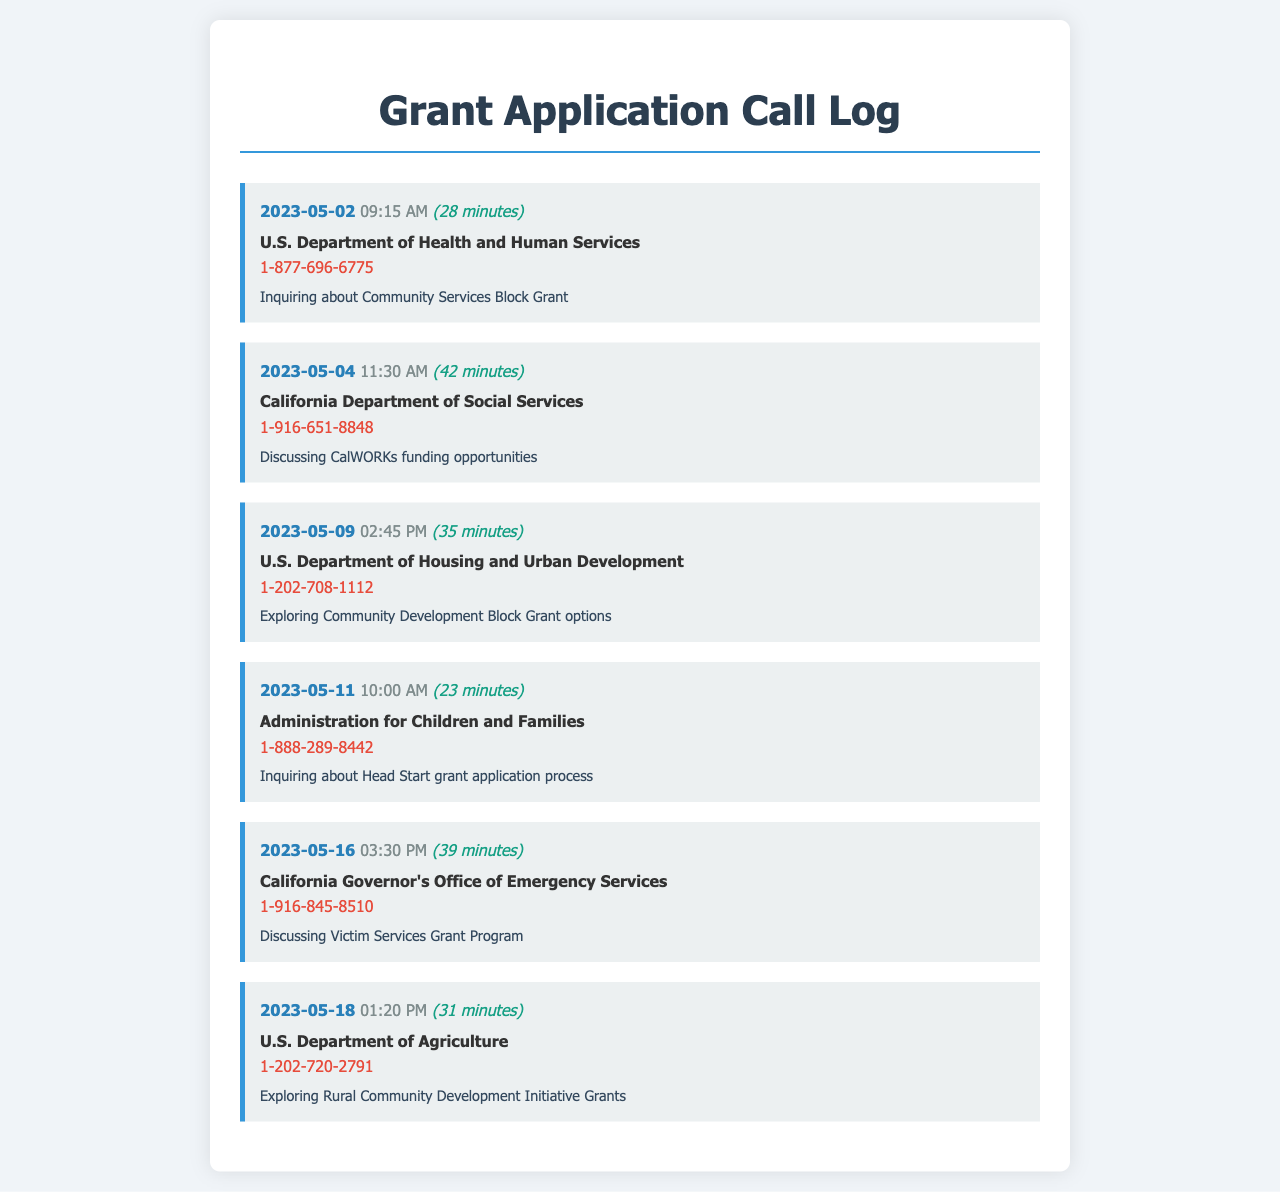what is the date of the first call? The first call is logged on May 2, 2023.
Answer: May 2, 2023 which agency was contacted regarding the CalWORKs funding? The call regarding CalWORKs funding was made to the California Department of Social Services.
Answer: California Department of Social Services how long was the call about Community Development Block Grant options? The duration of the call about Community Development Block Grant options was 35 minutes.
Answer: 35 minutes what was the purpose of the call to the U.S. Department of Agriculture? The purpose of the call to the U.S. Department of Agriculture was to explore Rural Community Development Initiative Grants.
Answer: Exploring Rural Community Development Initiative Grants how many minutes in total were spent on calls about grant applications? The total duration of all calls is 28 + 42 + 35 + 23 + 39 + 31 minutes. The sum is 198 minutes, meaning the total is 198 minutes.
Answer: 198 minutes which call had the shortest duration? The shortest call was with the Administration for Children and Families, lasting 23 minutes.
Answer: 23 minutes who was contacted on May 16, 2023? On May 16, 2023, the California Governor's Office of Emergency Services was contacted.
Answer: California Governor's Office of Emergency Services how many minutes were spent on the call about the Head Start grant application? The call about the Head Start grant application lasted 23 minutes.
Answer: 23 minutes 